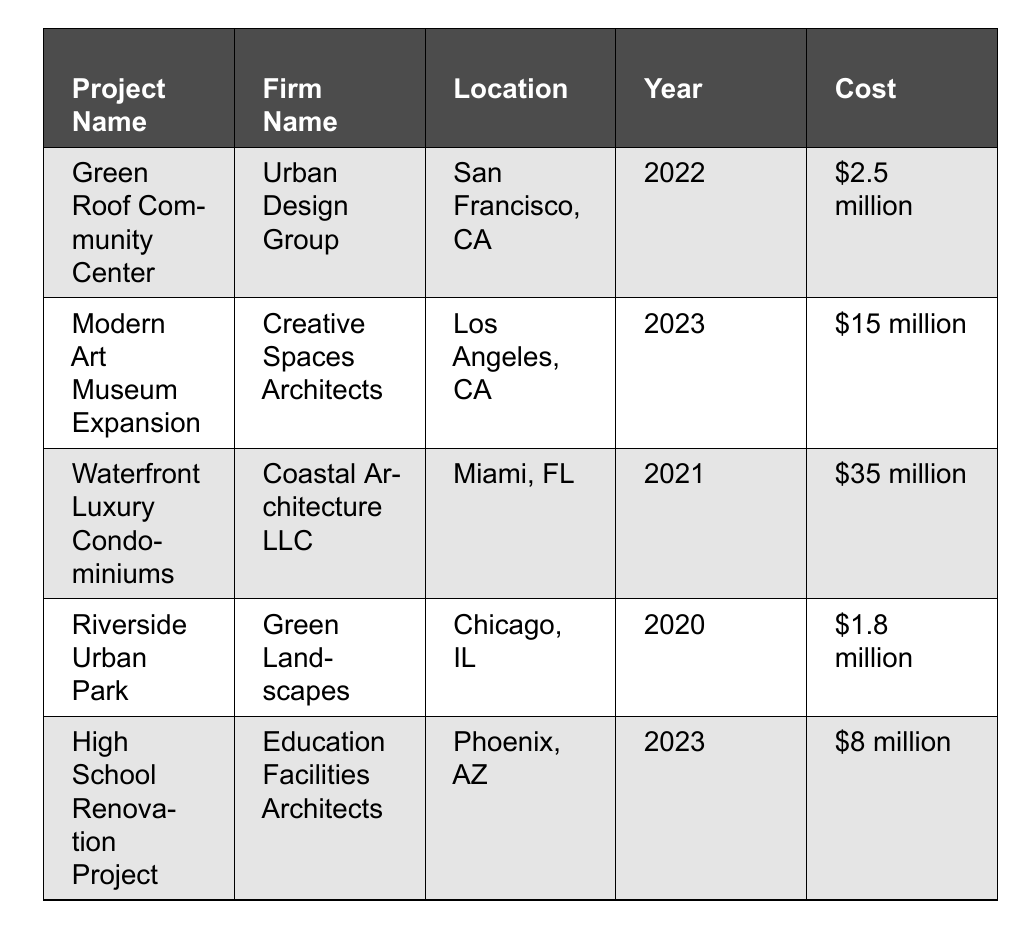What is the project name with the highest cost? The projects listed are "Green Roof Community Center" ($2.5 million), "Modern Art Museum Expansion" ($15 million), "Waterfront Luxury Condominiums" ($35 million), "Riverside Urban Park" ($1.8 million), and "High School Renovation Project" ($8 million). Among these, "Waterfront Luxury Condominiums" has the highest cost at $35 million.
Answer: Waterfront Luxury Condominiums Which firm completed the "Modern Art Museum Expansion"? According to the table, the firm that completed the "Modern Art Museum Expansion" is "Creative Spaces Architects". This information is clearly stated in the corresponding row of the table.
Answer: Creative Spaces Architects How many projects were completed in 2023? There are two projects listed that were completed in 2023: "Modern Art Museum Expansion" and "High School Renovation Project". By counting the entries in the table for the year 2023, we find a total of two projects.
Answer: 2 What is the total project cost for all projects completed in 2022? The table shows one project completed in 2022: "Green Roof Community Center" at $2.5 million. Since there is only one project from that year, the total cost is the same as its cost: $2.5 million.
Answer: $2.5 million Is the "Riverside Urban Park" project a residential type? The "Riverside Urban Park" is categorized as a "Public Park" in the table. This indicates that it is not a residential project. Therefore, the answer is no.
Answer: No Which architect worked on the Waterfront Luxury Condominiums project? From the table, it is evident that "Emily Chen" is the architect associated with the Waterfront Luxury Condominiums project. This can be found by looking at the row for this project in the table.
Answer: Emily Chen What is the average cost of the projects completed between 2021 and 2023? The projects completed between 2021 and 2023 are: "Waterfront Luxury Condominiums" ($35 million), "Modern Art Museum Expansion" ($15 million), "High School Renovation Project" ($8 million). To find the average, we add the costs (35 + 15 + 8 = 58 million) and divide by the number of projects (3). This gives us an average cost of approximately $19.33 million.
Answer: $19.33 million What notable feature is mentioned for the "High School Renovation Project"? The "High School Renovation Project" has the notable features of "Modernized classrooms, updated technology infrastructure" as indicated in the respective row in the table.
Answer: Modernized classrooms, updated technology infrastructure Which project has a location in Chicago, IL? "Riverside Urban Park" is the project located in Chicago, IL. This can be identified by checking the location column for each project in the table.
Answer: Riverside Urban Park Was the "Green Roof Community Center" completed before 2021? The completion year for the "Green Roof Community Center" is 2022, which is after 2021. This means the statement is false.
Answer: No 